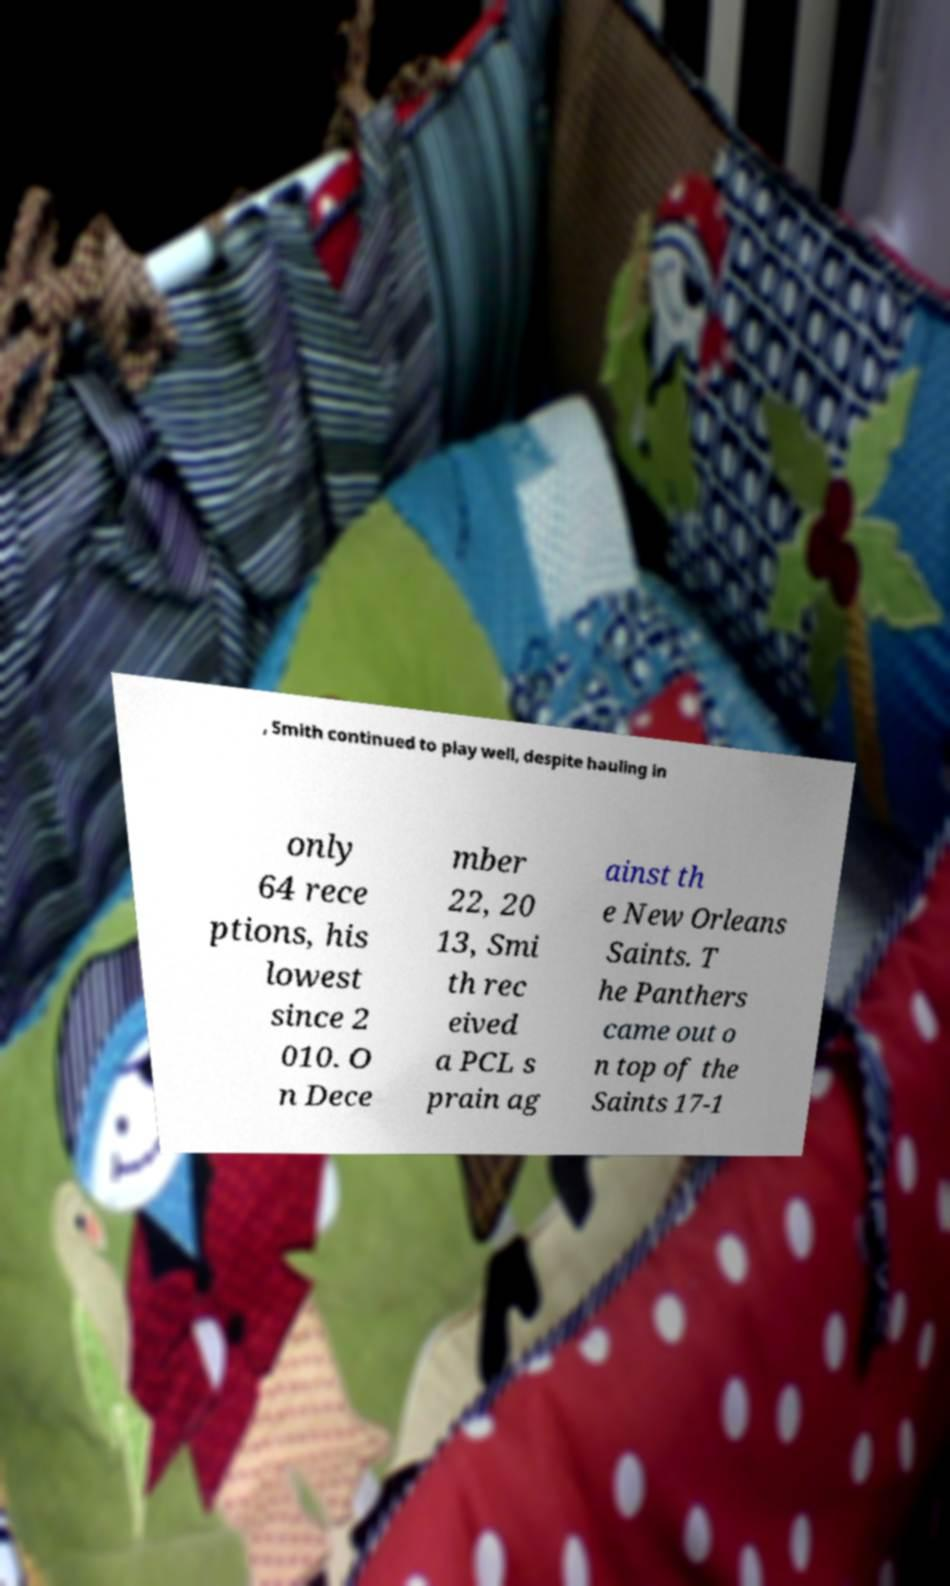What messages or text are displayed in this image? I need them in a readable, typed format. , Smith continued to play well, despite hauling in only 64 rece ptions, his lowest since 2 010. O n Dece mber 22, 20 13, Smi th rec eived a PCL s prain ag ainst th e New Orleans Saints. T he Panthers came out o n top of the Saints 17-1 